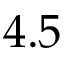<formula> <loc_0><loc_0><loc_500><loc_500>4 . 5</formula> 